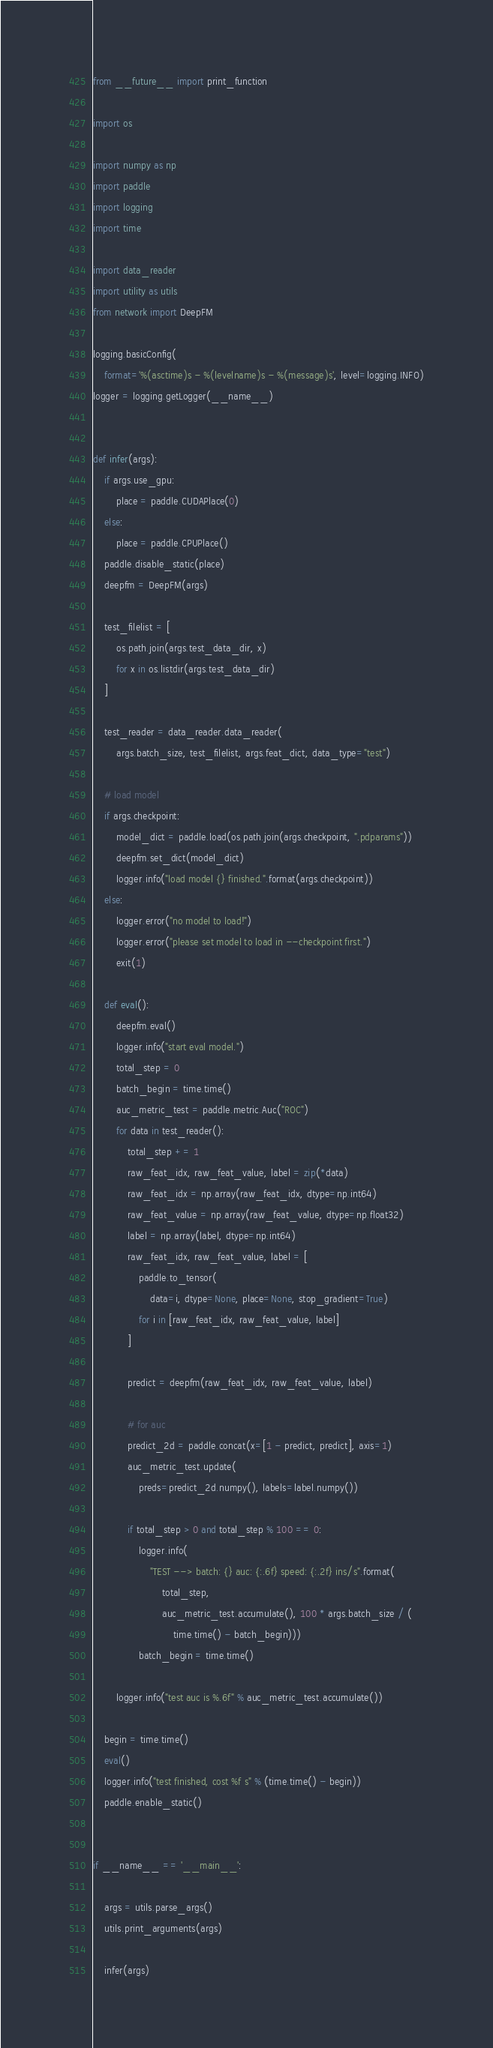Convert code to text. <code><loc_0><loc_0><loc_500><loc_500><_Python_>from __future__ import print_function

import os

import numpy as np
import paddle
import logging
import time

import data_reader
import utility as utils
from network import DeepFM

logging.basicConfig(
    format='%(asctime)s - %(levelname)s - %(message)s', level=logging.INFO)
logger = logging.getLogger(__name__)


def infer(args):
    if args.use_gpu:
        place = paddle.CUDAPlace(0)
    else:
        place = paddle.CPUPlace()
    paddle.disable_static(place)
    deepfm = DeepFM(args)

    test_filelist = [
        os.path.join(args.test_data_dir, x)
        for x in os.listdir(args.test_data_dir)
    ]

    test_reader = data_reader.data_reader(
        args.batch_size, test_filelist, args.feat_dict, data_type="test")

    # load model
    if args.checkpoint:
        model_dict = paddle.load(os.path.join(args.checkpoint, ".pdparams"))
        deepfm.set_dict(model_dict)
        logger.info("load model {} finished.".format(args.checkpoint))
    else:
        logger.error("no model to load!")
        logger.error("please set model to load in --checkpoint first.")
        exit(1)

    def eval():
        deepfm.eval()
        logger.info("start eval model.")
        total_step = 0
        batch_begin = time.time()
        auc_metric_test = paddle.metric.Auc("ROC")
        for data in test_reader():
            total_step += 1
            raw_feat_idx, raw_feat_value, label = zip(*data)
            raw_feat_idx = np.array(raw_feat_idx, dtype=np.int64)
            raw_feat_value = np.array(raw_feat_value, dtype=np.float32)
            label = np.array(label, dtype=np.int64)
            raw_feat_idx, raw_feat_value, label = [
                paddle.to_tensor(
                    data=i, dtype=None, place=None, stop_gradient=True)
                for i in [raw_feat_idx, raw_feat_value, label]
            ]

            predict = deepfm(raw_feat_idx, raw_feat_value, label)

            # for auc
            predict_2d = paddle.concat(x=[1 - predict, predict], axis=1)
            auc_metric_test.update(
                preds=predict_2d.numpy(), labels=label.numpy())

            if total_step > 0 and total_step % 100 == 0:
                logger.info(
                    "TEST --> batch: {} auc: {:.6f} speed: {:.2f} ins/s".format(
                        total_step,
                        auc_metric_test.accumulate(), 100 * args.batch_size / (
                            time.time() - batch_begin)))
                batch_begin = time.time()

        logger.info("test auc is %.6f" % auc_metric_test.accumulate())

    begin = time.time()
    eval()
    logger.info("test finished, cost %f s" % (time.time() - begin))
    paddle.enable_static()


if __name__ == '__main__':

    args = utils.parse_args()
    utils.print_arguments(args)

    infer(args)
</code> 